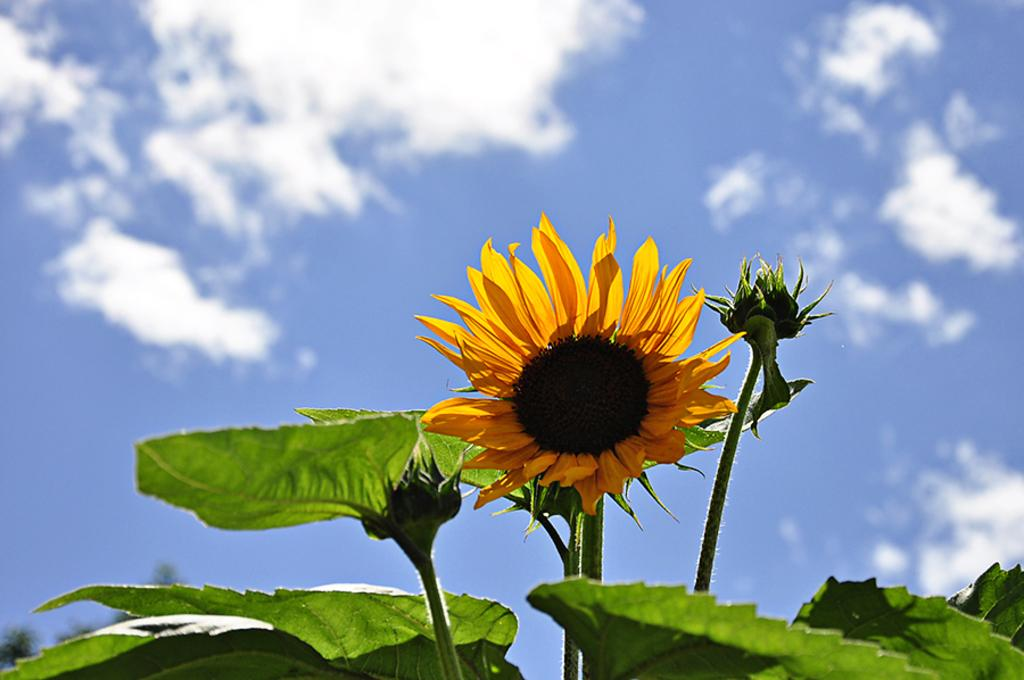What type of plants can be seen in the image? There are sunflower plants in the image. What can be seen in the background of the image? The sky is visible in the background of the image. What type of noise can be heard coming from the sunflower plants in the image? There is no noise coming from the sunflower plants in the image, as plants do not produce sound. 